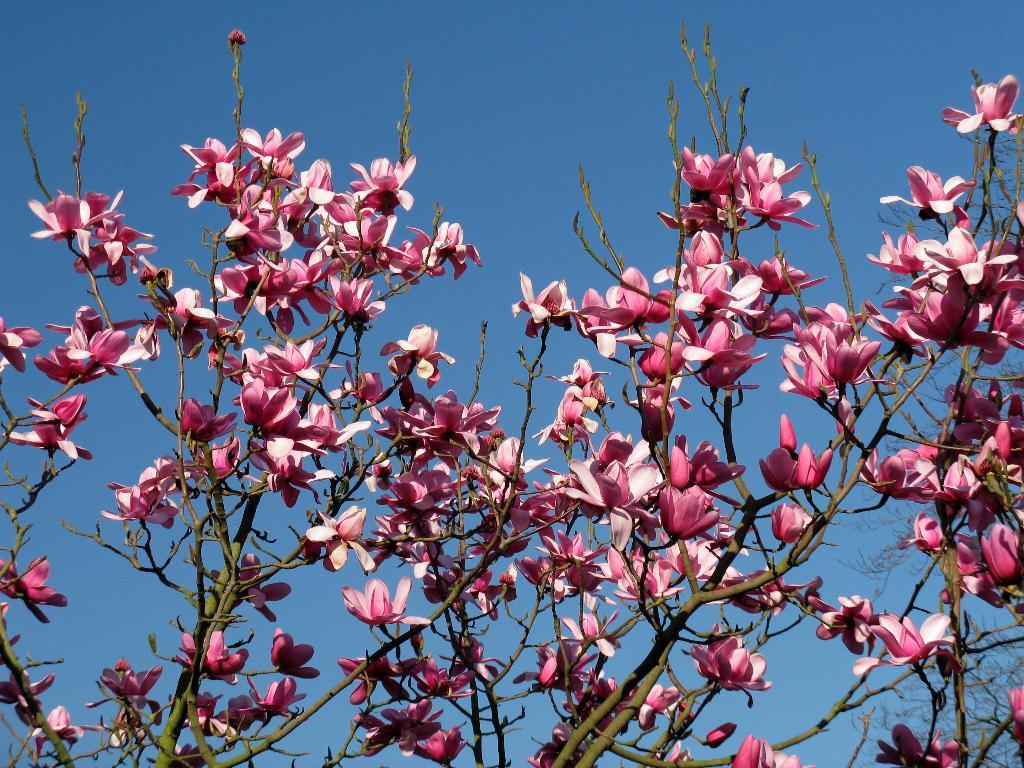What type of plant can be seen in the image? There is a tree in the image. What color are the flowers on the tree? The flowers on the tree are pink. Can you see any cactus plants in the image? There is no cactus plant present in the image; it features a tree with pink flowers. Is the tree located near the sea in the image? There is no reference to the sea in the image, as it only features a tree with pink flowers. 